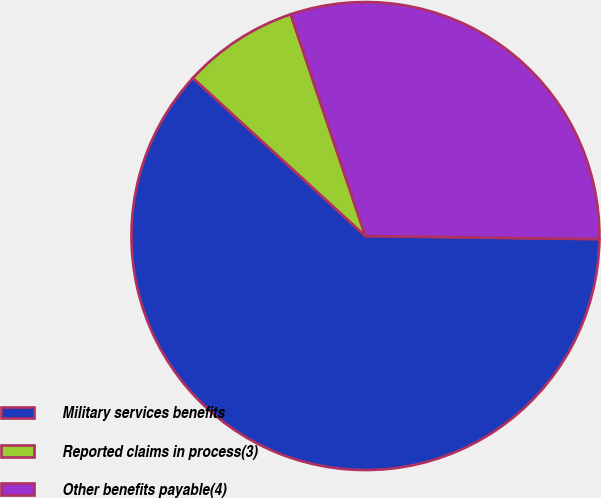Convert chart. <chart><loc_0><loc_0><loc_500><loc_500><pie_chart><fcel>Military services benefits<fcel>Reported claims in process(3)<fcel>Other benefits payable(4)<nl><fcel>61.59%<fcel>8.03%<fcel>30.38%<nl></chart> 